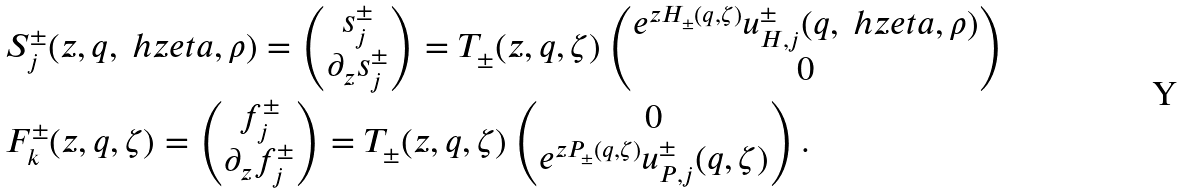Convert formula to latex. <formula><loc_0><loc_0><loc_500><loc_500>& S _ { j } ^ { \pm } ( z , q , \ h z e t a , \rho ) = \begin{pmatrix} s _ { j } ^ { \pm } \\ \partial _ { z } s ^ { \pm } _ { j } \end{pmatrix} = T _ { \pm } ( z , q , \zeta ) \begin{pmatrix} e ^ { z H _ { \pm } ( q , \zeta ) } u _ { H , j } ^ { \pm } ( q , \ h z e t a , \rho ) \\ 0 \end{pmatrix} \\ & F _ { k } ^ { \pm } ( z , q , \zeta ) = \begin{pmatrix} f _ { j } ^ { \pm } \\ \partial _ { z } f ^ { \pm } _ { j } \end{pmatrix} = T _ { \pm } ( z , q , \zeta ) \begin{pmatrix} 0 \\ e ^ { z P _ { \pm } ( q , \zeta ) } u _ { P , j } ^ { \pm } ( q , \zeta ) \end{pmatrix} .</formula> 